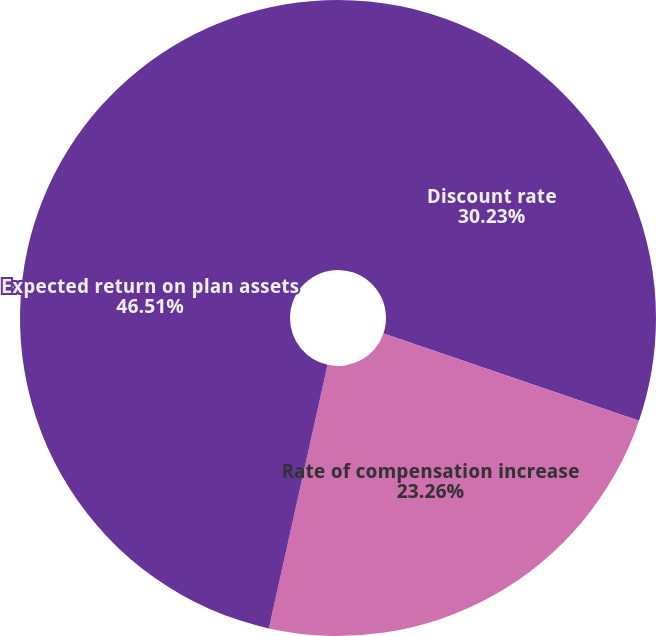<chart> <loc_0><loc_0><loc_500><loc_500><pie_chart><fcel>Discount rate<fcel>Rate of compensation increase<fcel>Expected return on plan assets<nl><fcel>30.23%<fcel>23.26%<fcel>46.51%<nl></chart> 